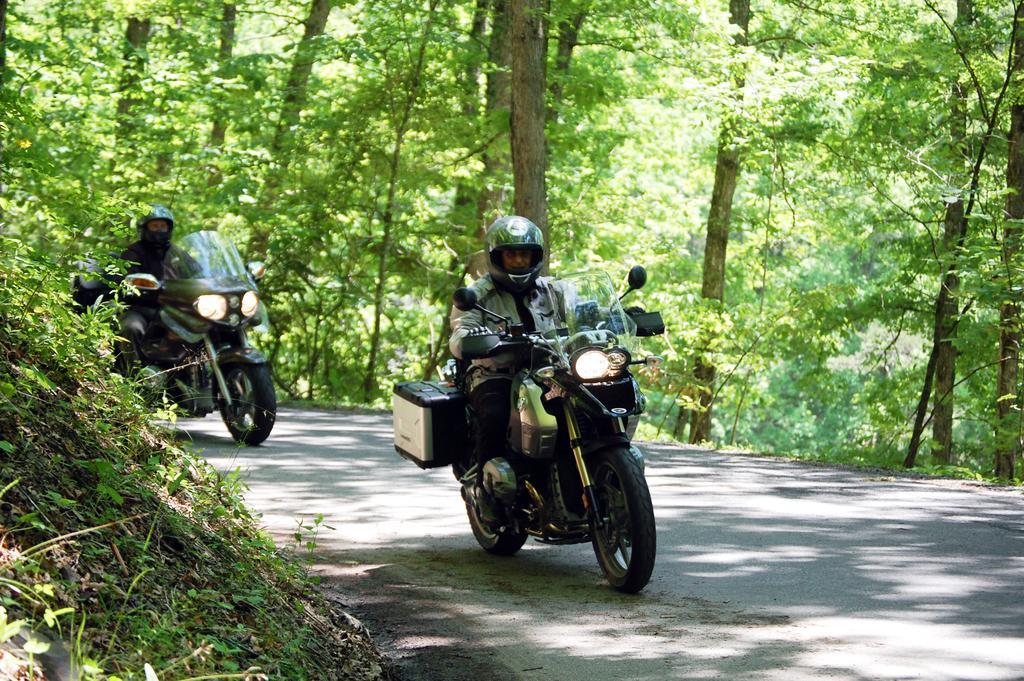Describe this image in one or two sentences. In this image we can see two persons wearing helmets and jackets are riding motorbikes on the road. Here we can see planets and the trees in the background. 